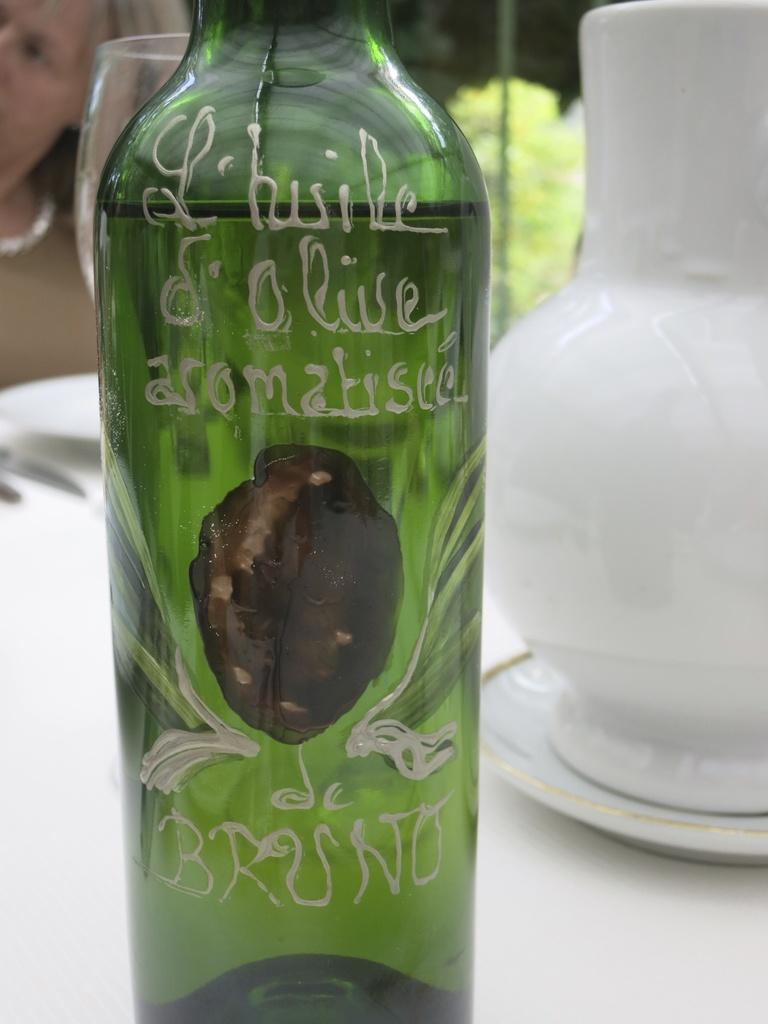What piece of furniture is present in the image? There is a table in the image. What objects can be seen on the table? There is a glass bottle and a ceramic jar on the table, with the jar placed on a plate. Can you describe the woman in the image? The woman in the image has blond hair and is wearing a necklace. Where is the woman sitting in relation to the table? The woman is sitting at the end of the table. What type of fight is taking place between the ceramic jar and the glass bottle in the image? There is no fight taking place between the ceramic jar and the glass bottle in the image; they are simply objects placed on the table. Can you tell me how much sand is present in the image? There is no sand present in the image. 